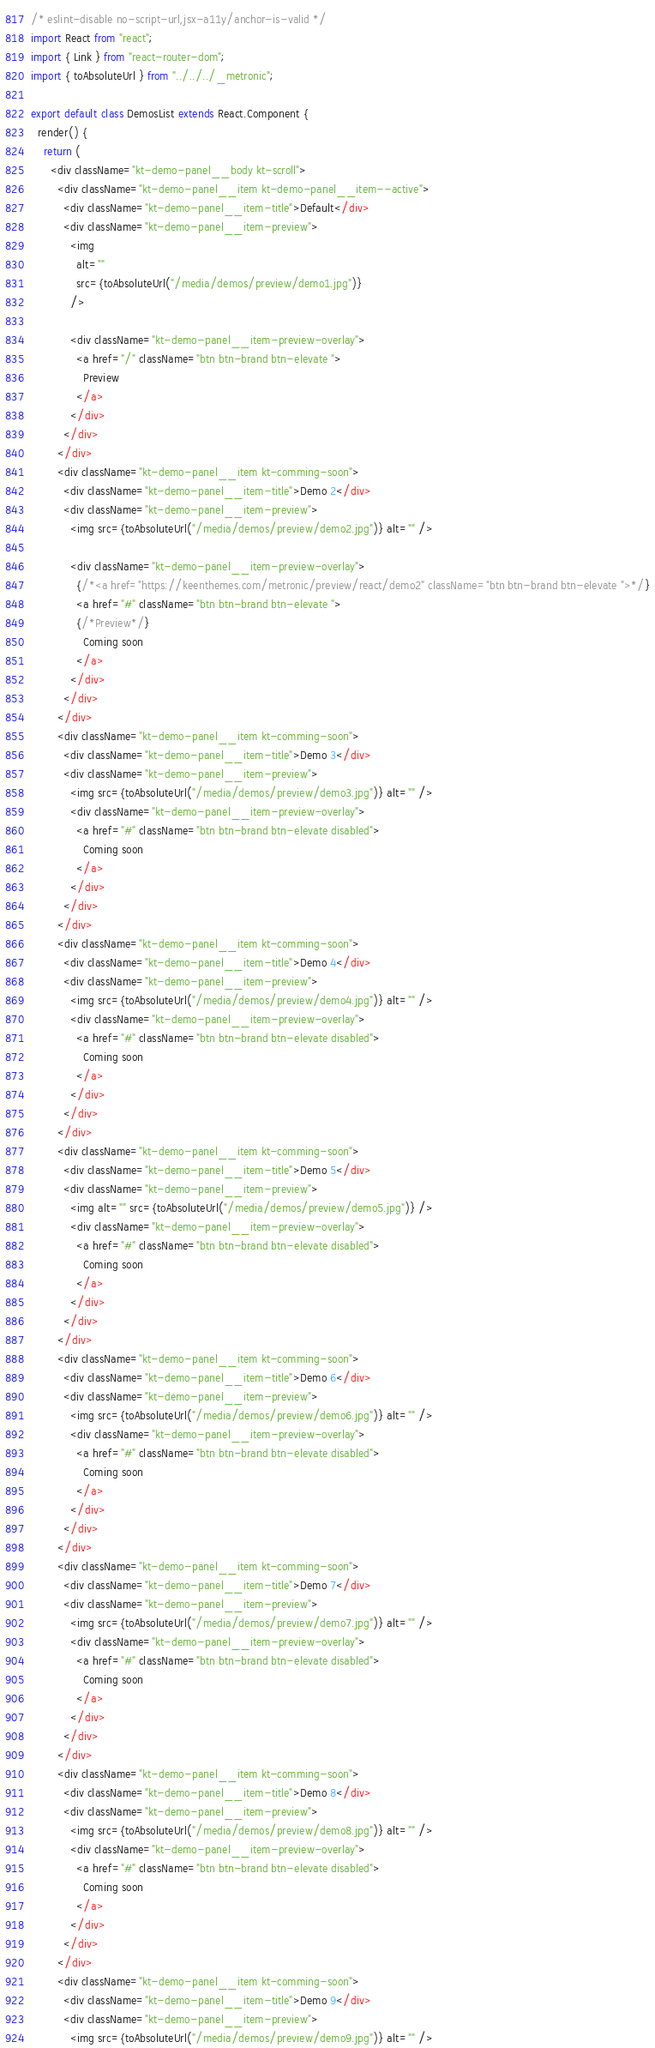<code> <loc_0><loc_0><loc_500><loc_500><_JavaScript_>/* eslint-disable no-script-url,jsx-a11y/anchor-is-valid */
import React from "react";
import { Link } from "react-router-dom";
import { toAbsoluteUrl } from "../../../_metronic";

export default class DemosList extends React.Component {
  render() {
    return (
      <div className="kt-demo-panel__body kt-scroll">
        <div className="kt-demo-panel__item kt-demo-panel__item--active">
          <div className="kt-demo-panel__item-title">Default</div>
          <div className="kt-demo-panel__item-preview">
            <img
              alt=""
              src={toAbsoluteUrl("/media/demos/preview/demo1.jpg")}
            />

            <div className="kt-demo-panel__item-preview-overlay">
              <a href="/" className="btn btn-brand btn-elevate ">
                Preview
              </a>
            </div>
          </div>
        </div>
        <div className="kt-demo-panel__item kt-comming-soon">
          <div className="kt-demo-panel__item-title">Demo 2</div>
          <div className="kt-demo-panel__item-preview">
            <img src={toAbsoluteUrl("/media/demos/preview/demo2.jpg")} alt="" />

            <div className="kt-demo-panel__item-preview-overlay">
              {/*<a href="https://keenthemes.com/metronic/preview/react/demo2" className="btn btn-brand btn-elevate ">*/}
              <a href="#" className="btn btn-brand btn-elevate ">
              {/*Preview*/}
                Coming soon
              </a>
            </div>
          </div>
        </div>
        <div className="kt-demo-panel__item kt-comming-soon">
          <div className="kt-demo-panel__item-title">Demo 3</div>
          <div className="kt-demo-panel__item-preview">
            <img src={toAbsoluteUrl("/media/demos/preview/demo3.jpg")} alt="" />
            <div className="kt-demo-panel__item-preview-overlay">
              <a href="#" className="btn btn-brand btn-elevate disabled">
                Coming soon
              </a>
            </div>
          </div>
        </div>
        <div className="kt-demo-panel__item kt-comming-soon">
          <div className="kt-demo-panel__item-title">Demo 4</div>
          <div className="kt-demo-panel__item-preview">
            <img src={toAbsoluteUrl("/media/demos/preview/demo4.jpg")} alt="" />
            <div className="kt-demo-panel__item-preview-overlay">
              <a href="#" className="btn btn-brand btn-elevate disabled">
                Coming soon
              </a>
            </div>
          </div>
        </div>
        <div className="kt-demo-panel__item kt-comming-soon">
          <div className="kt-demo-panel__item-title">Demo 5</div>
          <div className="kt-demo-panel__item-preview">
            <img alt="" src={toAbsoluteUrl("/media/demos/preview/demo5.jpg")} />
            <div className="kt-demo-panel__item-preview-overlay">
              <a href="#" className="btn btn-brand btn-elevate disabled">
                Coming soon
              </a>
            </div>
          </div>
        </div>
        <div className="kt-demo-panel__item kt-comming-soon">
          <div className="kt-demo-panel__item-title">Demo 6</div>
          <div className="kt-demo-panel__item-preview">
            <img src={toAbsoluteUrl("/media/demos/preview/demo6.jpg")} alt="" />
            <div className="kt-demo-panel__item-preview-overlay">
              <a href="#" className="btn btn-brand btn-elevate disabled">
                Coming soon
              </a>
            </div>
          </div>
        </div>
        <div className="kt-demo-panel__item kt-comming-soon">
          <div className="kt-demo-panel__item-title">Demo 7</div>
          <div className="kt-demo-panel__item-preview">
            <img src={toAbsoluteUrl("/media/demos/preview/demo7.jpg")} alt="" />
            <div className="kt-demo-panel__item-preview-overlay">
              <a href="#" className="btn btn-brand btn-elevate disabled">
                Coming soon
              </a>
            </div>
          </div>
        </div>
        <div className="kt-demo-panel__item kt-comming-soon">
          <div className="kt-demo-panel__item-title">Demo 8</div>
          <div className="kt-demo-panel__item-preview">
            <img src={toAbsoluteUrl("/media/demos/preview/demo8.jpg")} alt="" />
            <div className="kt-demo-panel__item-preview-overlay">
              <a href="#" className="btn btn-brand btn-elevate disabled">
                Coming soon
              </a>
            </div>
          </div>
        </div>
        <div className="kt-demo-panel__item kt-comming-soon">
          <div className="kt-demo-panel__item-title">Demo 9</div>
          <div className="kt-demo-panel__item-preview">
            <img src={toAbsoluteUrl("/media/demos/preview/demo9.jpg")} alt="" /></code> 